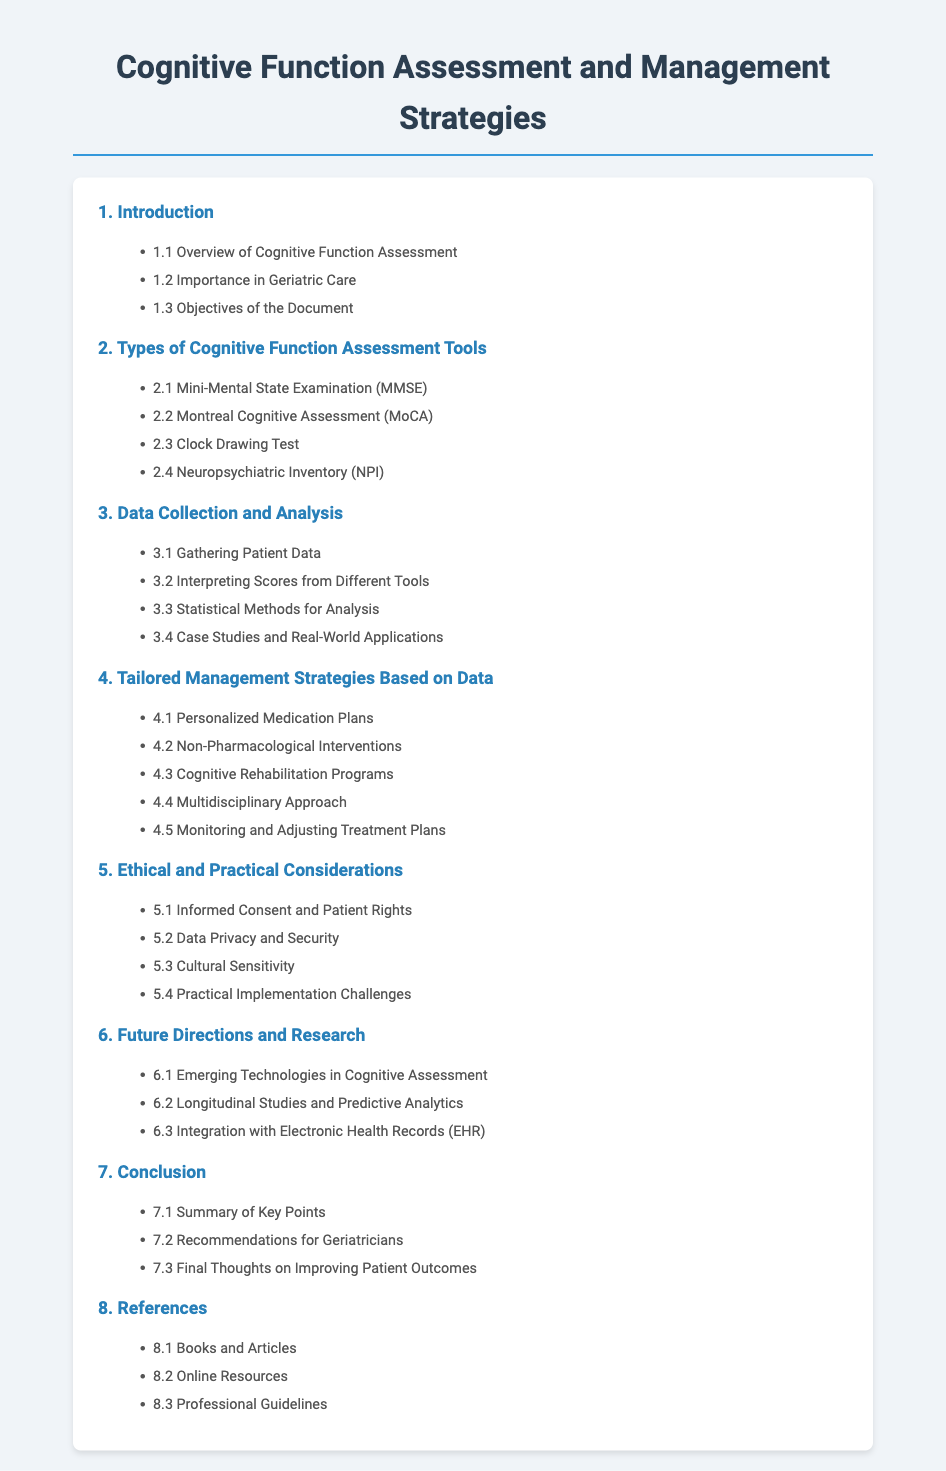What section covers the importance of cognitive assessment in geriatric care? The document outlines the importance in Geriatric Care in section 1.2.
Answer: 1.2 Importance in Geriatric Care What is the first cognitive assessment tool mentioned? The first cognitive assessment tool listed in section 2 is the Mini-Mental State Examination.
Answer: 2.1 Mini-Mental State Examination (MMSE) How many methods for data analysis are listed? There are four statistical methods for analysis mentioned in section 3.3.
Answer: 3.3 Statistical Methods for Analysis What is one of the tailored management strategies based on data? A personalized medication plan is listed as a tailored management strategy in section 4.1.
Answer: 4.1 Personalized Medication Plans Which section discusses monitoring and adjusting treatment plans? Monitoring and Adjusting Treatment Plans is found in section 4.5.
Answer: 4.5 Monitoring and Adjusting Treatment Plans What ethical consideration is addressed in the document? Informed Consent and Patient Rights is a topic covered in section 5.1.
Answer: 5.1 Informed Consent and Patient Rights What is mentioned as a future direction for cognitive assessments? Emerging Technologies in Cognitive Assessment is discussed in section 6.1.
Answer: 6.1 Emerging Technologies in Cognitive Assessment What final recommendations are made for geriatricians? Recommendations for Geriatricians is in section 7.2 of the document.
Answer: 7.2 Recommendations for Geriatricians 